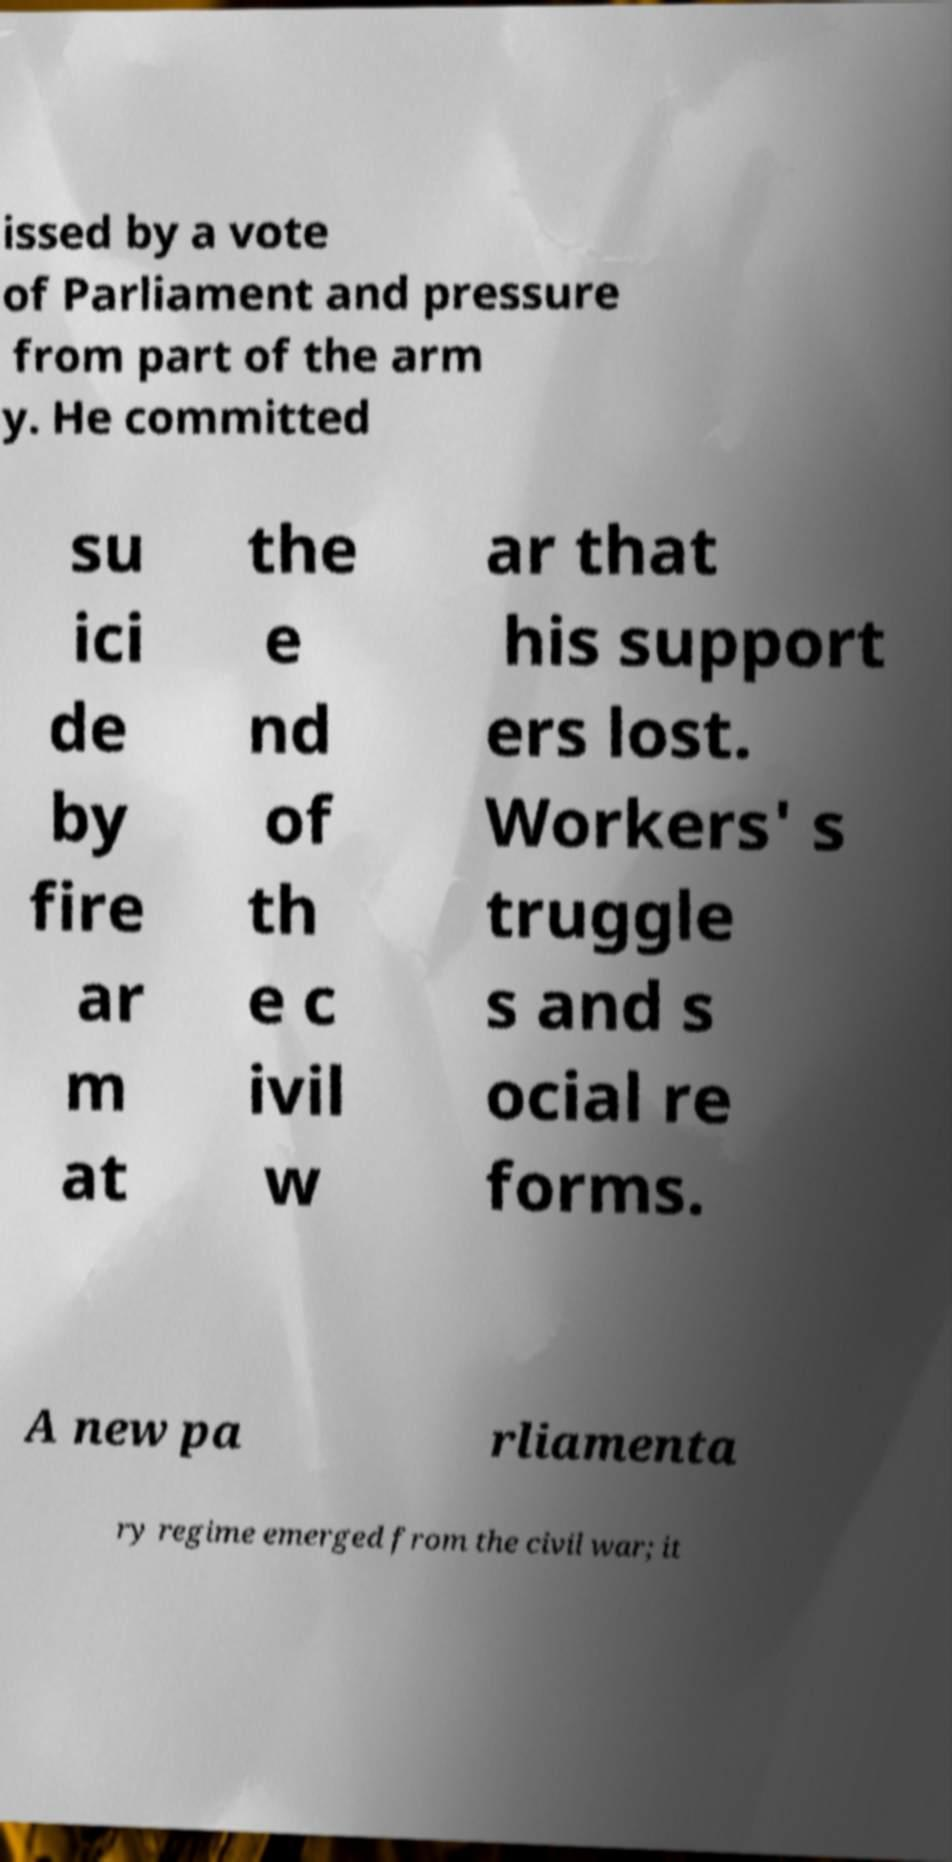Please read and relay the text visible in this image. What does it say? issed by a vote of Parliament and pressure from part of the arm y. He committed su ici de by fire ar m at the e nd of th e c ivil w ar that his support ers lost. Workers' s truggle s and s ocial re forms. A new pa rliamenta ry regime emerged from the civil war; it 